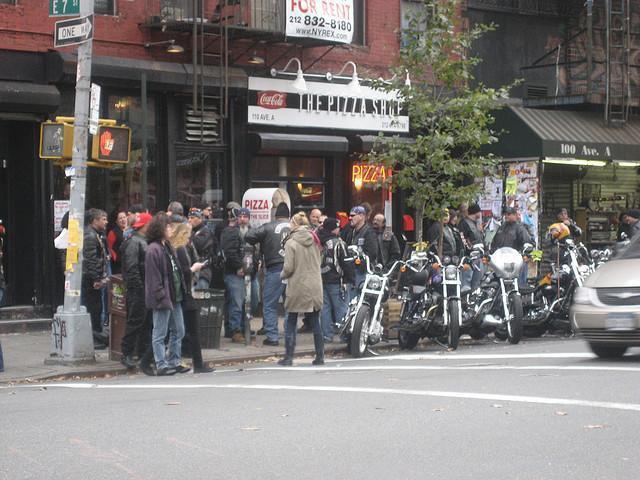What will the bikers shown here have for lunch today?
Select the accurate answer and provide explanation: 'Answer: answer
Rationale: rationale.'
Options: Hot dogs, steak, pizza, salads. Answer: pizza.
Rationale: The bikers get pizza. 